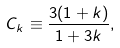Convert formula to latex. <formula><loc_0><loc_0><loc_500><loc_500>C _ { k } \equiv \frac { 3 ( 1 + k ) } { 1 + 3 k } ,</formula> 